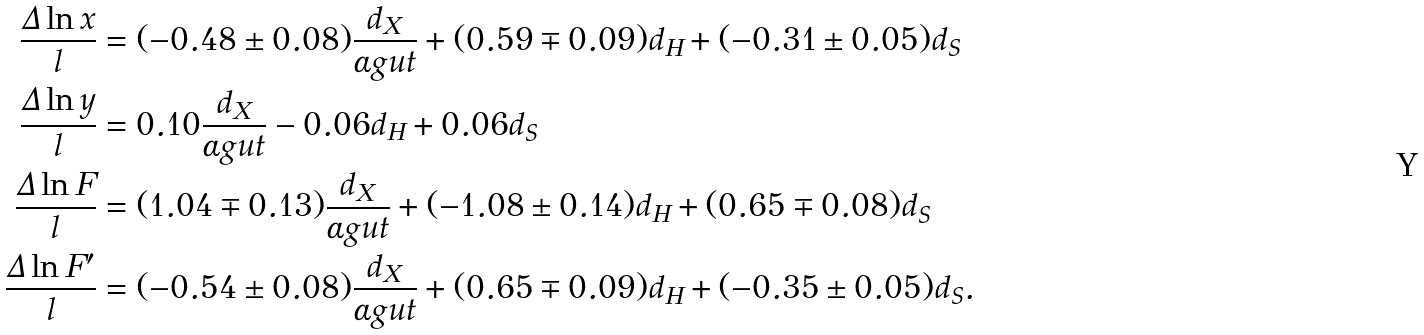Convert formula to latex. <formula><loc_0><loc_0><loc_500><loc_500>\frac { \Delta \ln x } { l } & = ( - 0 . 4 8 \pm 0 . 0 8 ) \frac { d _ { X } } { \alpha g u t } + ( 0 . 5 9 \mp 0 . 0 9 ) d _ { H } + ( - 0 . 3 1 \pm 0 . 0 5 ) d _ { S } \\ \frac { \Delta \ln y } { l } & = 0 . 1 0 \frac { d _ { X } } { \alpha g u t } - 0 . 0 6 d _ { H } + 0 . 0 6 d _ { S } \\ \frac { \Delta \ln F } { l } & = ( 1 . 0 4 \mp 0 . 1 3 ) \frac { d _ { X } } { \alpha g u t } + ( - 1 . 0 8 \pm 0 . 1 4 ) d _ { H } + ( 0 . 6 5 \mp 0 . 0 8 ) d _ { S } \\ \frac { \Delta \ln F ^ { \prime } } { l } & = ( - 0 . 5 4 \pm 0 . 0 8 ) \frac { d _ { X } } { \alpha g u t } + ( 0 . 6 5 \mp 0 . 0 9 ) d _ { H } + ( - 0 . 3 5 \pm 0 . 0 5 ) d _ { S } .</formula> 